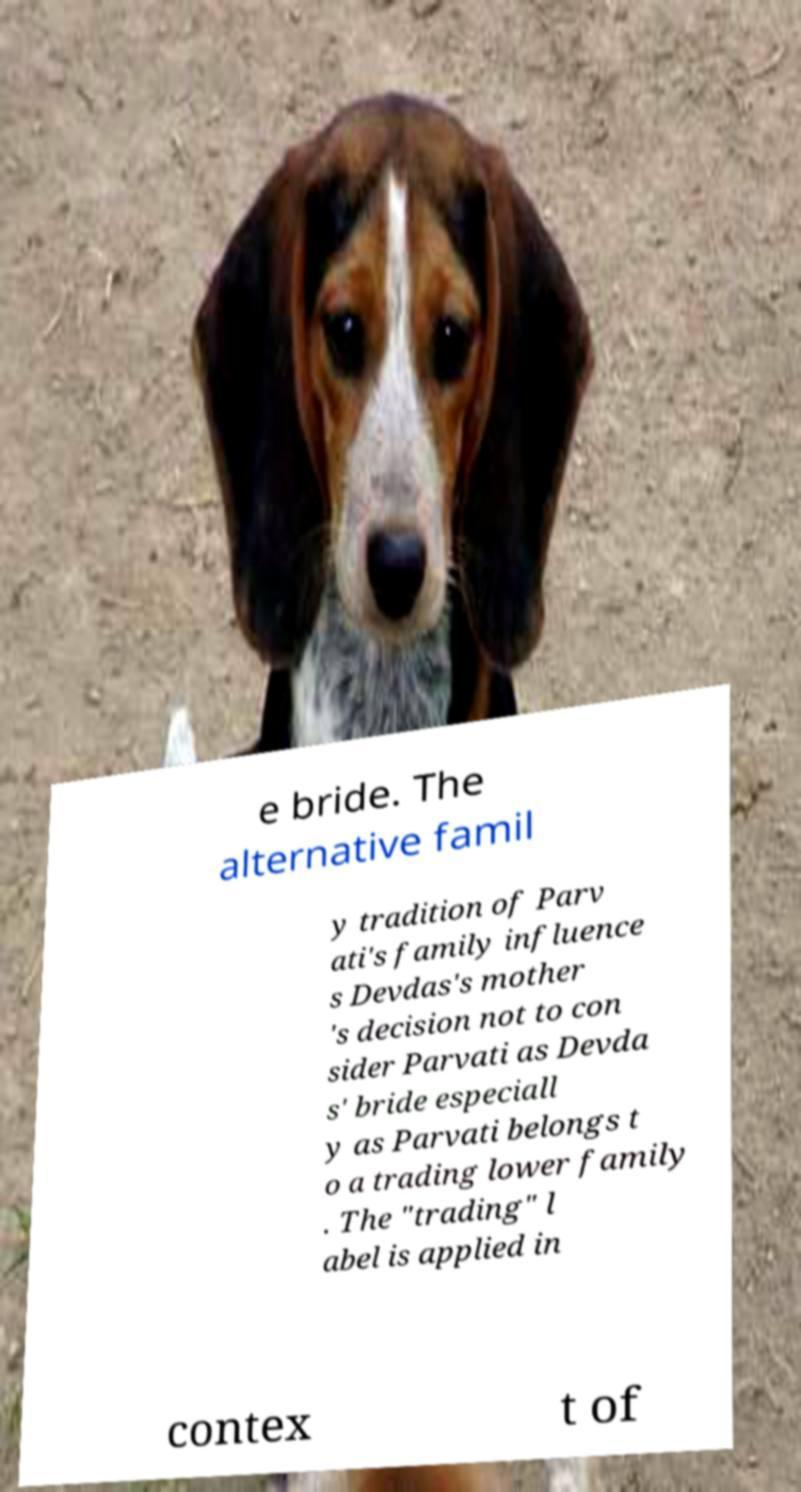There's text embedded in this image that I need extracted. Can you transcribe it verbatim? e bride. The alternative famil y tradition of Parv ati's family influence s Devdas's mother 's decision not to con sider Parvati as Devda s' bride especiall y as Parvati belongs t o a trading lower family . The "trading" l abel is applied in contex t of 